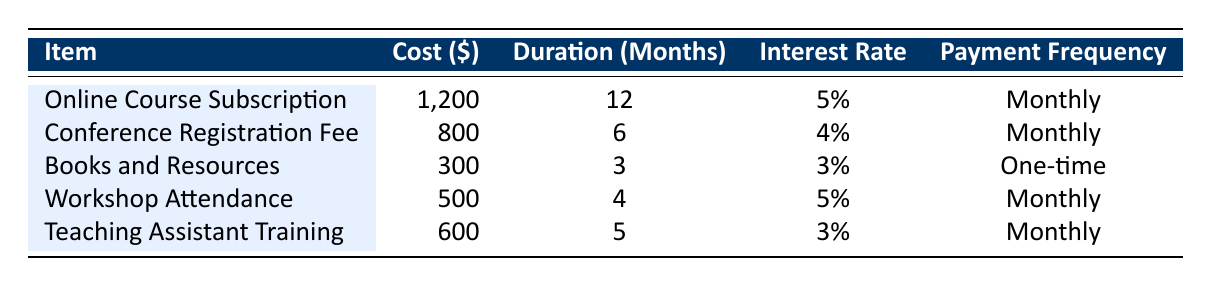What is the cost of the Online Course Subscription? The cost of the Online Course Subscription is directly listed in the table under the "Cost" column for that item. It is 1,200 dollars.
Answer: 1,200 How many months does the Conference Registration Fee last? The duration for the Conference Registration Fee is specified in the table under the "Duration" column, which indicates it lasts for 6 months.
Answer: 6 months What is the interest rate for the Books and Resources expense? The interest rate for the Books and Resources is given in the table under the "Interest Rate" column, which shows it as 3 percent.
Answer: 3% How much do I pay in total for Taking Assistant Training? The Teaching Assistant Training costs 600 dollars, and since it is paid monthly over 5 months, the total payment will be 600 dollars (one-time payment).
Answer: 600 What is the average interest rate of all listed expenses? The interest rates for each item are 5%, 4%, 3%, 5%, and 3%. To find the average, we sum them up: (5 + 4 + 3 + 5 + 3) = 20. Then, divide this total by the number of items (5), resulting in an average interest rate of 20/5 = 4%.
Answer: 4% Is the total cost of the Workshop Attendance higher than that of the Books and Resources? The cost of the Workshop Attendance is 500 dollars, while the cost of the Books and Resources is 300 dollars. Comparing these values, 500 is higher than 300, thus the answer is yes.
Answer: Yes How many items have a payment frequency of Monthly? By checking the "Payment Frequency" column, the items that have "Monthly" are: Online Course Subscription, Conference Registration Fee, Workshop Attendance, and Teaching Assistant Training. This totals to four items.
Answer: 4 Which item has the highest cost and what is the amount? To find the highest cost, we compare the costs: 1,200 (Online Course Subscription), 800 (Conference Registration Fee), 300 (Books and Resources), 500 (Workshop Attendance), and 600 (Teaching Assistant Training). The highest is 1,200 for the Online Course Subscription.
Answer: Online Course Subscription, 1,200 What is the total cost of all expenses? The total cost of all expenses can be found by adding up the individual costs: 1,200 (Online Course Subscription) + 800 (Conference Registration Fee) + 300 (Books and Resources) + 500 (Workshop Attendance) + 600 (Teaching Assistant Training) = 3,400.
Answer: 3,400 Is there any item that requires a one-time payment? The table specifies that the Books and Resources expense has a "Payment Frequency" of "One-time," indicating that there is indeed an item requiring a one-time payment.
Answer: Yes 